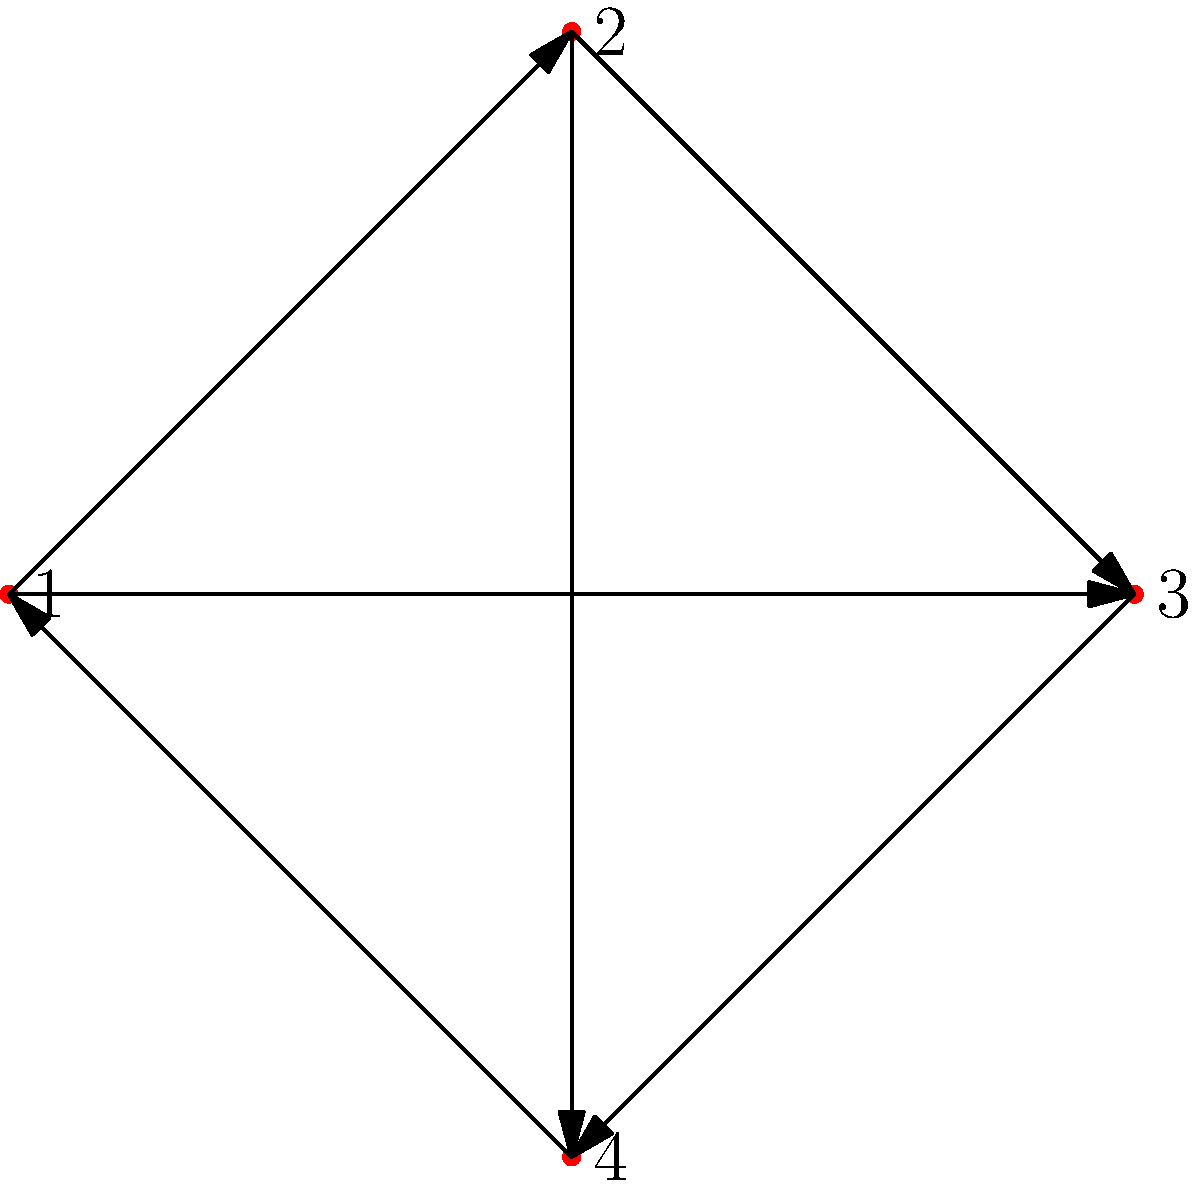Consider the directed graph representing a crop rotation schedule for traditional Italian vegetables. Each vertex represents a crop: 1 - Tomatoes, 2 - Basil, 3 - Zucchini, 4 - Garlic. Edges indicate valid crop rotations. What is the minimum number of years required to complete a rotation cycle that includes all four crops without repeating any crop? To solve this problem, we need to find the shortest path that visits all vertices exactly once and returns to the starting point. This is known as the Hamiltonian cycle.

Step 1: Identify all possible Hamiltonian cycles in the graph.
- 1 → 2 → 3 → 4 → 1
- 1 → 3 → 4 → 2 → 1

Step 2: Verify that these are the only two valid Hamiltonian cycles.
- Both cycles visit all four vertices exactly once and return to the starting point.
- No other combination of edges forms a valid Hamiltonian cycle.

Step 3: Count the number of edges in each cycle.
- Both cycles contain 4 edges.

Step 4: Interpret the result in terms of crop rotation.
- Each edge represents a year in the rotation schedule.
- The number of edges in the cycle represents the number of years to complete the rotation.

Therefore, the minimum number of years required to complete a rotation cycle that includes all four crops without repeating any crop is 4 years.
Answer: 4 years 